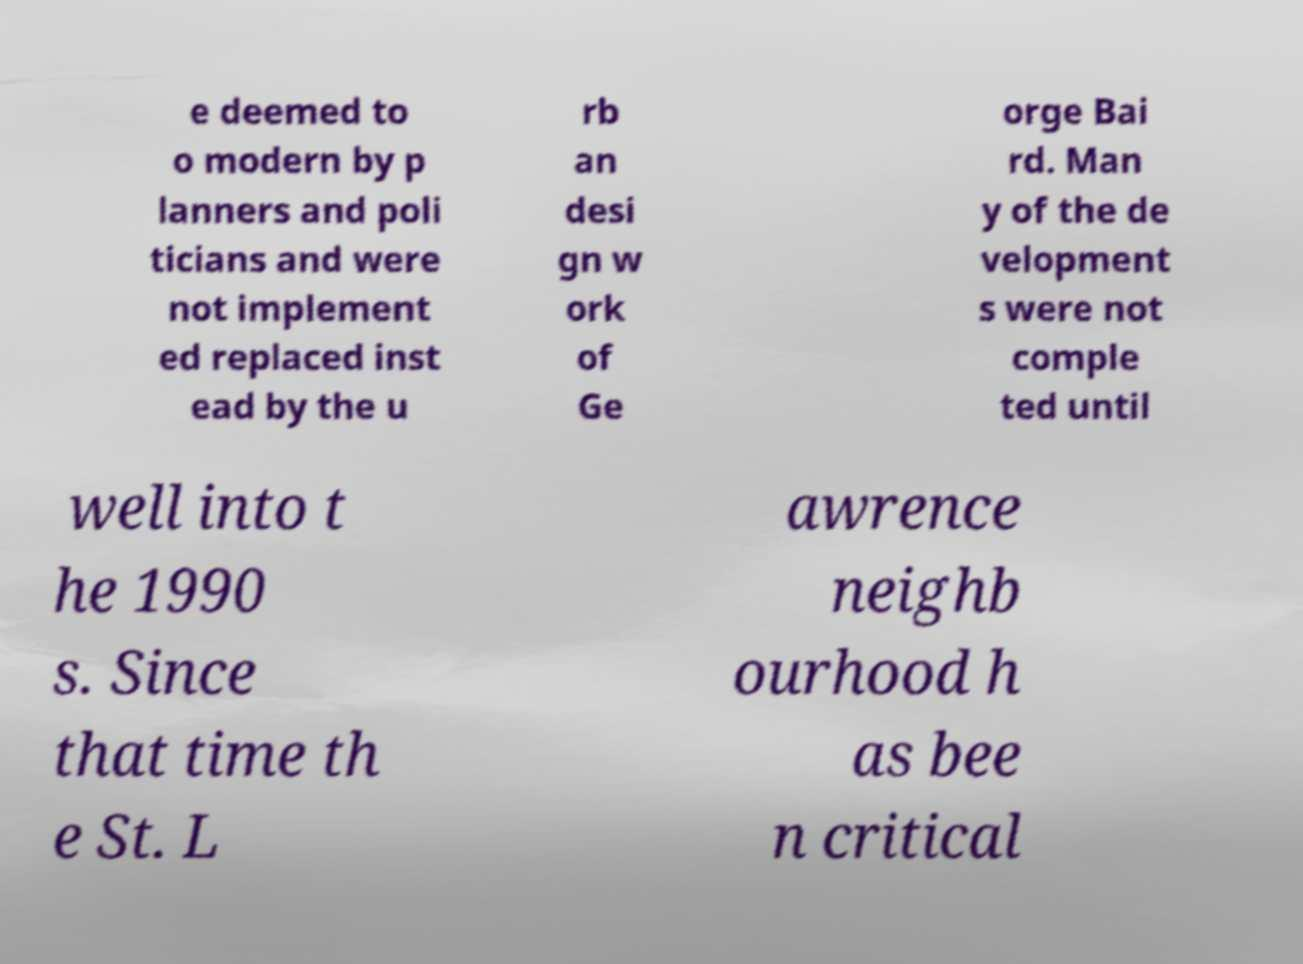Could you extract and type out the text from this image? e deemed to o modern by p lanners and poli ticians and were not implement ed replaced inst ead by the u rb an desi gn w ork of Ge orge Bai rd. Man y of the de velopment s were not comple ted until well into t he 1990 s. Since that time th e St. L awrence neighb ourhood h as bee n critical 